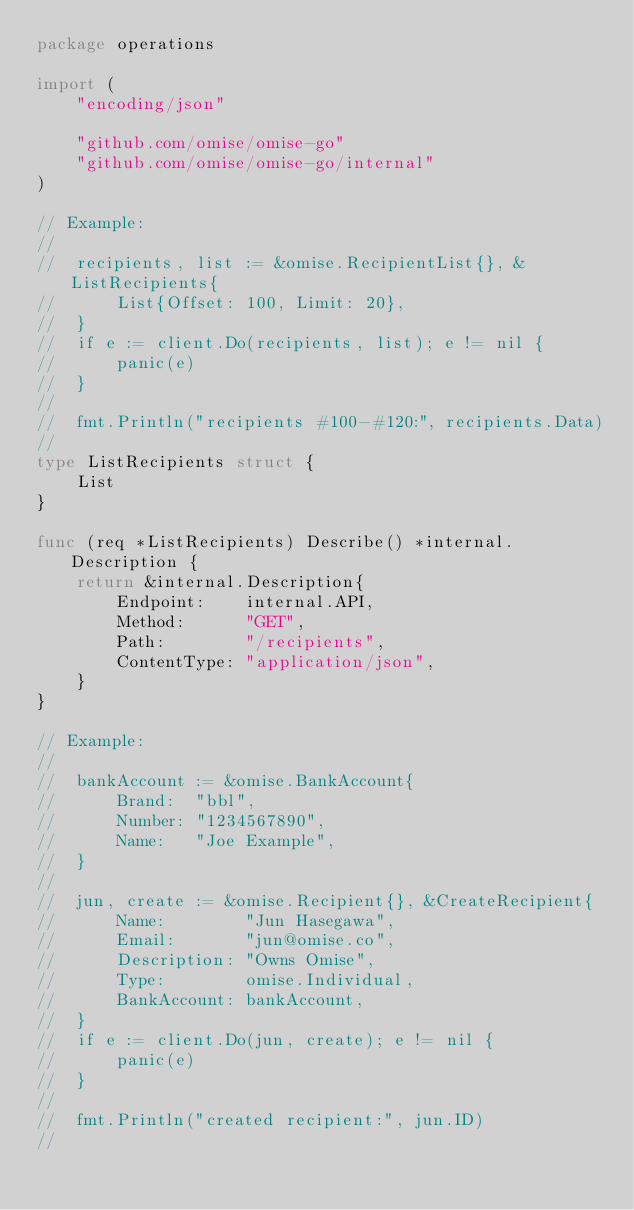<code> <loc_0><loc_0><loc_500><loc_500><_Go_>package operations

import (
	"encoding/json"

	"github.com/omise/omise-go"
	"github.com/omise/omise-go/internal"
)

// Example:
//
//	recipients, list := &omise.RecipientList{}, &ListRecipients{
//		List{Offset: 100, Limit: 20},
//	}
//	if e := client.Do(recipients, list); e != nil {
//		panic(e)
//	}
//
//	fmt.Println("recipients #100-#120:", recipients.Data)
//
type ListRecipients struct {
	List
}

func (req *ListRecipients) Describe() *internal.Description {
	return &internal.Description{
		Endpoint:    internal.API,
		Method:      "GET",
		Path:        "/recipients",
		ContentType: "application/json",
	}
}

// Example:
//
//	bankAccount := &omise.BankAccount{
//		Brand:  "bbl",
//		Number: "1234567890",
//		Name:   "Joe Example",
//	}
//
//	jun, create := &omise.Recipient{}, &CreateRecipient{
//		Name:        "Jun Hasegawa",
//		Email:       "jun@omise.co",
//		Description: "Owns Omise",
//		Type:        omise.Individual,
//		BankAccount: bankAccount,
//	}
//	if e := client.Do(jun, create); e != nil {
//		panic(e)
//	}
//
//	fmt.Println("created recipient:", jun.ID)
//</code> 